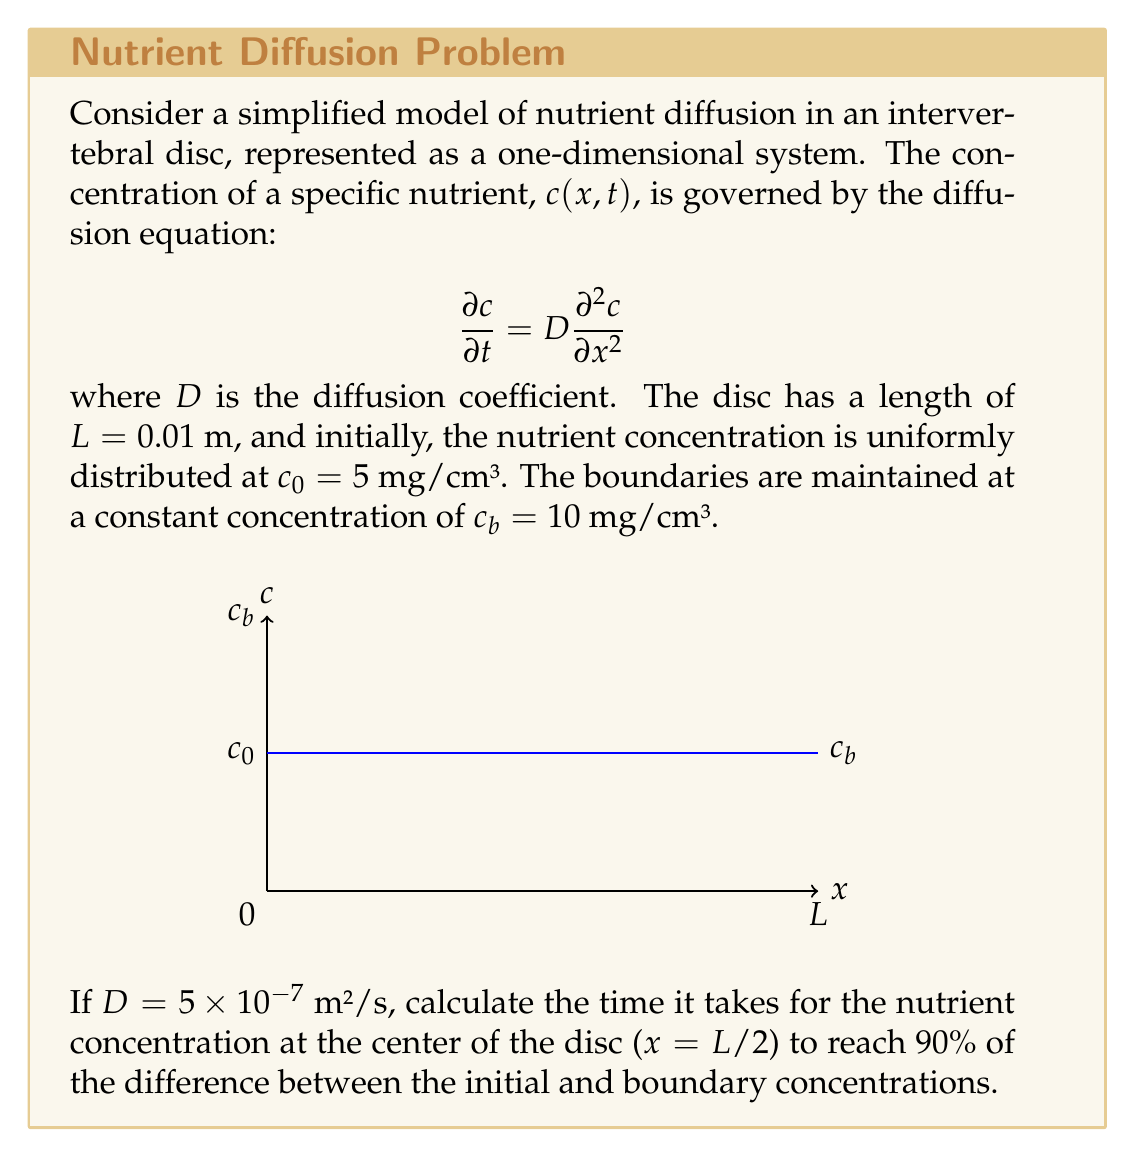Help me with this question. To solve this problem, we'll use the analytical solution of the diffusion equation for the given initial and boundary conditions:

1) The solution for this scenario is given by:

   $$c(x,t) = c_b - (c_b - c_0)\sum_{n=1}^{\infty}\frac{4}{\pi(2n-1)}\sin\left(\frac{(2n-1)\pi x}{L}\right)e^{-D\left(\frac{(2n-1)\pi}{L}\right)^2t}$$

2) At the center of the disc, $x = L/2$, so:

   $$c(L/2,t) = c_b - (c_b - c_0)\sum_{n=1}^{\infty}\frac{4}{\pi(2n-1)}\sin\left(\frac{(2n-1)\pi}{2}\right)e^{-D\left(\frac{(2n-1)\pi}{L}\right)^2t}$$

3) Note that $\sin\left(\frac{(2n-1)\pi}{2}\right) = (-1)^{n+1}$, so:

   $$c(L/2,t) = c_b - (c_b - c_0)\sum_{n=1}^{\infty}\frac{4(-1)^{n+1}}{\pi(2n-1)}e^{-D\left(\frac{(2n-1)\pi}{L}\right)^2t}$$

4) We want to find $t$ when $c(L/2,t) = c_0 + 0.9(c_b - c_0) = 9.5$ mg/cm³

5) Substituting the values:

   $$9.5 = 10 - 5\sum_{n=1}^{\infty}\frac{4(-1)^{n+1}}{\pi(2n-1)}e^{-5\times10^{-7}\left(\frac{(2n-1)\pi}{0.01}\right)^2t}$$

6) This equation can't be solved analytically for $t$. We need to use numerical methods or approximations.

7) A good approximation is to consider only the first term of the series (n=1):

   $$0.5 \approx 5\cdot\frac{4}{\pi}e^{-5\times10^{-7}\left(\frac{\pi}{0.01}\right)^2t}$$

8) Taking the natural logarithm of both sides:

   $$\ln(0.5\cdot\frac{\pi}{20}) \approx -5\times10^{-7}\left(\frac{\pi}{0.01}\right)^2t$$

9) Solving for $t$:

   $$t \approx \frac{\ln(0.5\cdot\frac{\pi}{20})}{-5\times10^{-7}\left(\frac{\pi}{0.01}\right)^2} \approx 0.0234 \text{ s}$$

Therefore, it takes approximately 0.0234 seconds for the nutrient concentration at the center of the disc to reach 90% of the difference between the initial and boundary concentrations.
Answer: $0.0234$ s 